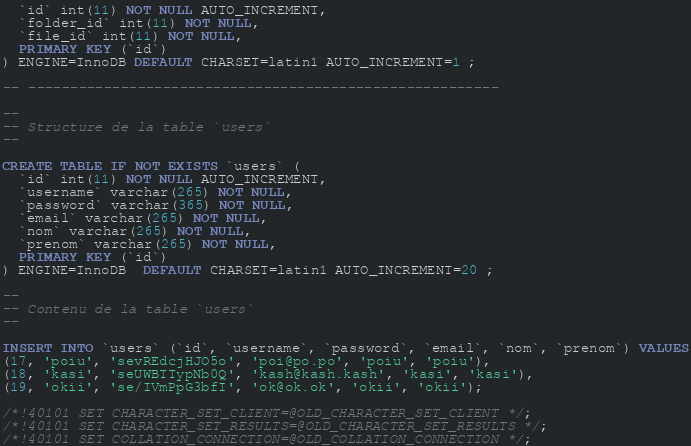Convert code to text. <code><loc_0><loc_0><loc_500><loc_500><_SQL_>  `id` int(11) NOT NULL AUTO_INCREMENT,
  `folder_id` int(11) NOT NULL,
  `file_id` int(11) NOT NULL,
  PRIMARY KEY (`id`)
) ENGINE=InnoDB DEFAULT CHARSET=latin1 AUTO_INCREMENT=1 ;

-- --------------------------------------------------------

--
-- Structure de la table `users`
--

CREATE TABLE IF NOT EXISTS `users` (
  `id` int(11) NOT NULL AUTO_INCREMENT,
  `username` varchar(265) NOT NULL,
  `password` varchar(365) NOT NULL,
  `email` varchar(265) NOT NULL,
  `nom` varchar(265) NOT NULL,
  `prenom` varchar(265) NOT NULL,
  PRIMARY KEY (`id`)
) ENGINE=InnoDB  DEFAULT CHARSET=latin1 AUTO_INCREMENT=20 ;

--
-- Contenu de la table `users`
--

INSERT INTO `users` (`id`, `username`, `password`, `email`, `nom`, `prenom`) VALUES
(17, 'poiu', 'sevREdcjHJO5o', 'poi@po.po', 'poiu', 'poiu'),
(18, 'kasi', 'seUWBTTypNb0Q', 'kash@kash.kash', 'kasi', 'kasi'),
(19, 'okii', 'se/IVmPpG3bfI', 'ok@ok.ok', 'okii', 'okii');

/*!40101 SET CHARACTER_SET_CLIENT=@OLD_CHARACTER_SET_CLIENT */;
/*!40101 SET CHARACTER_SET_RESULTS=@OLD_CHARACTER_SET_RESULTS */;
/*!40101 SET COLLATION_CONNECTION=@OLD_COLLATION_CONNECTION */;
</code> 